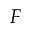Convert formula to latex. <formula><loc_0><loc_0><loc_500><loc_500>F</formula> 